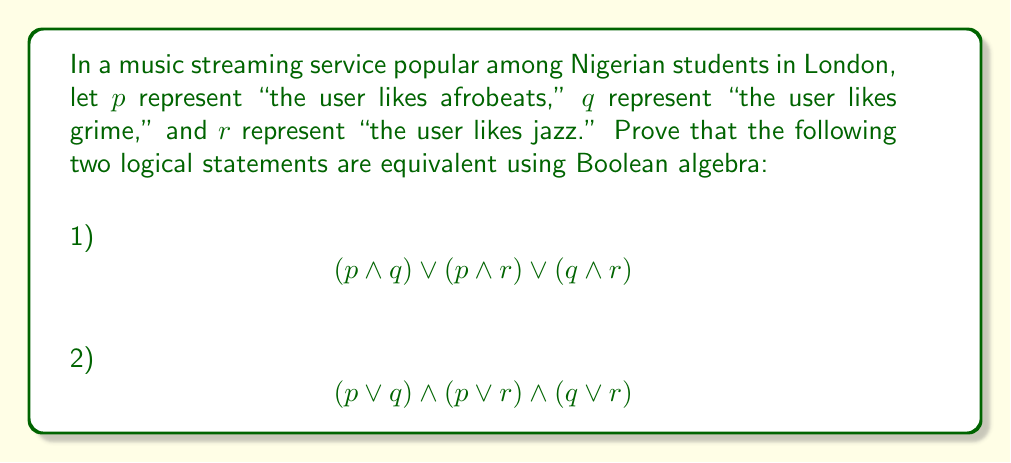Give your solution to this math problem. To prove the equivalence of these two logical statements, we'll use Boolean algebra laws and properties. Let's start with the second statement and transform it into the first.

Step 1: Begin with statement 2
$$(p \lor q) \land (p \lor r) \land (q \lor r)$$

Step 2: Apply the distributive law to the first two terms
$$((p \lor q) \land p) \lor ((p \lor q) \land r)$$

Step 3: Use the absorption law on $(p \lor q) \land p$, which simplifies to $p$
$$p \lor ((p \lor q) \land r)$$

Step 4: Apply the distributive law to $(p \lor q) \land r$
$$p \lor (p \land r) \lor (q \land r)$$

Step 5: Use the commutative law to rearrange the terms
$$(p \land r) \lor p \lor (q \land r)$$

Step 6: Apply the absorption law again, this time to $p \lor (p \land r)$, which simplifies to $p$
$$p \lor (q \land r)$$

Step 7: Use the distributive law one more time
$$(p \land q) \lor (p \land r) \lor (q \land r)$$

This final expression is identical to statement 1, proving that the two statements are equivalent.
Answer: The two logical statements are equivalent:
$$(p \land q) \lor (p \land r) \lor (q \land r) \equiv (p \lor q) \land (p \lor r) \land (q \lor r)$$ 